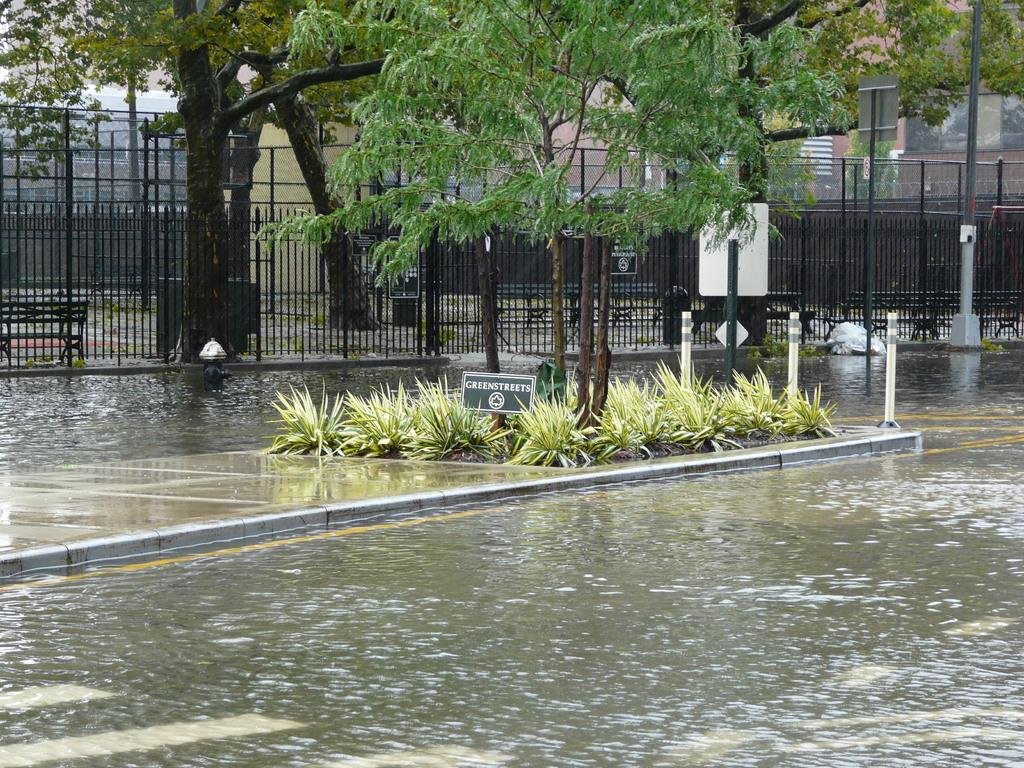What type of vegetation can be seen in the image? There are plants and trees in the image. What is located in the middle of the image? There is a board in the middle of the image. What is the condition of the road in the image? There is water on the road in the image. What can be seen in the background of the image? There is a fence, a building, and other plants in the background of the image. What type of fear is depicted in the image? There is no fear depicted in the image; it features plants, trees, a board, water on the road, a fence, a building, and other plants in the background. What type of quilt is used to cover the board in the image? There is no quilt present in the image; it features plants, trees, a board, water on the road, a fence, a building, and other plants in the background. 